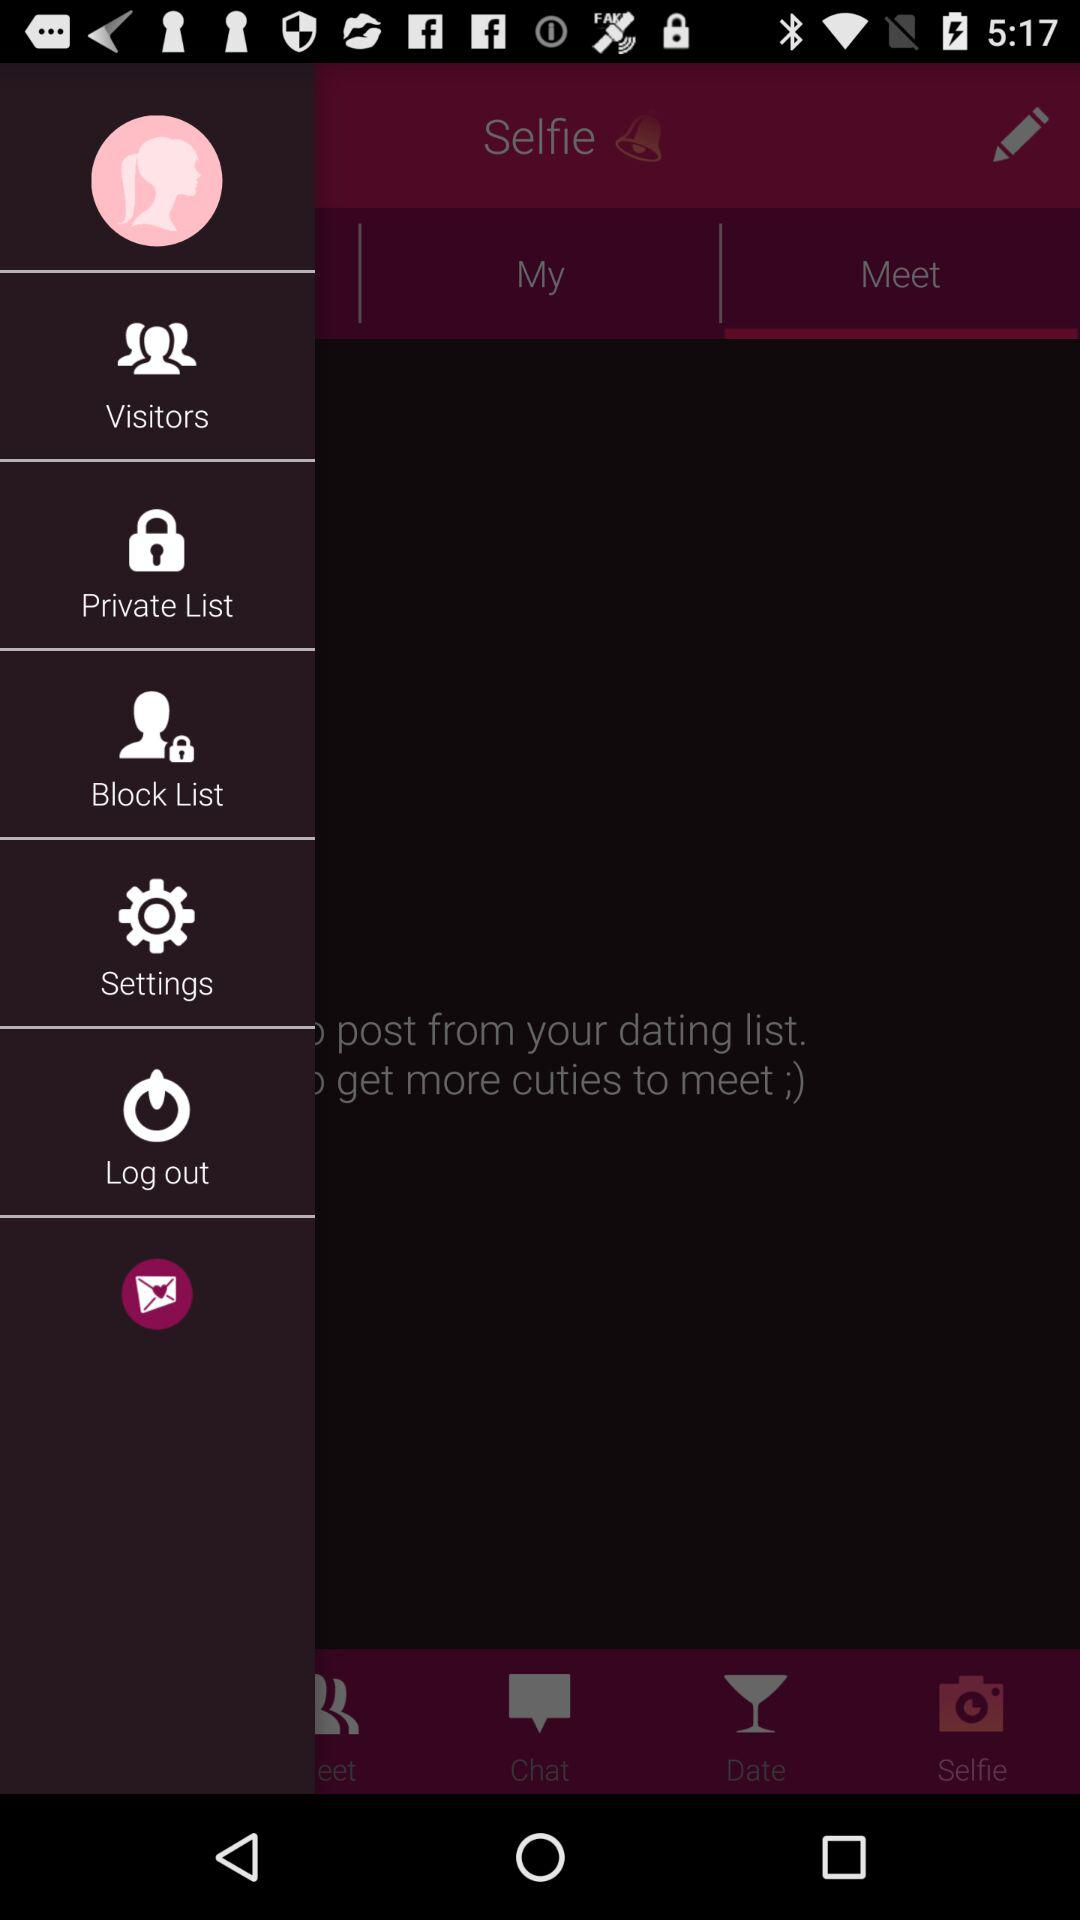Which tab is selected in the top row? The selected tab in the top row is "Meet". 